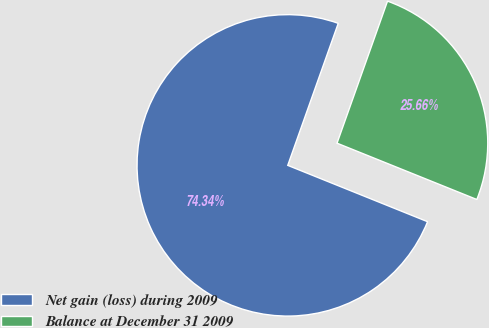Convert chart to OTSL. <chart><loc_0><loc_0><loc_500><loc_500><pie_chart><fcel>Net gain (loss) during 2009<fcel>Balance at December 31 2009<nl><fcel>74.34%<fcel>25.66%<nl></chart> 